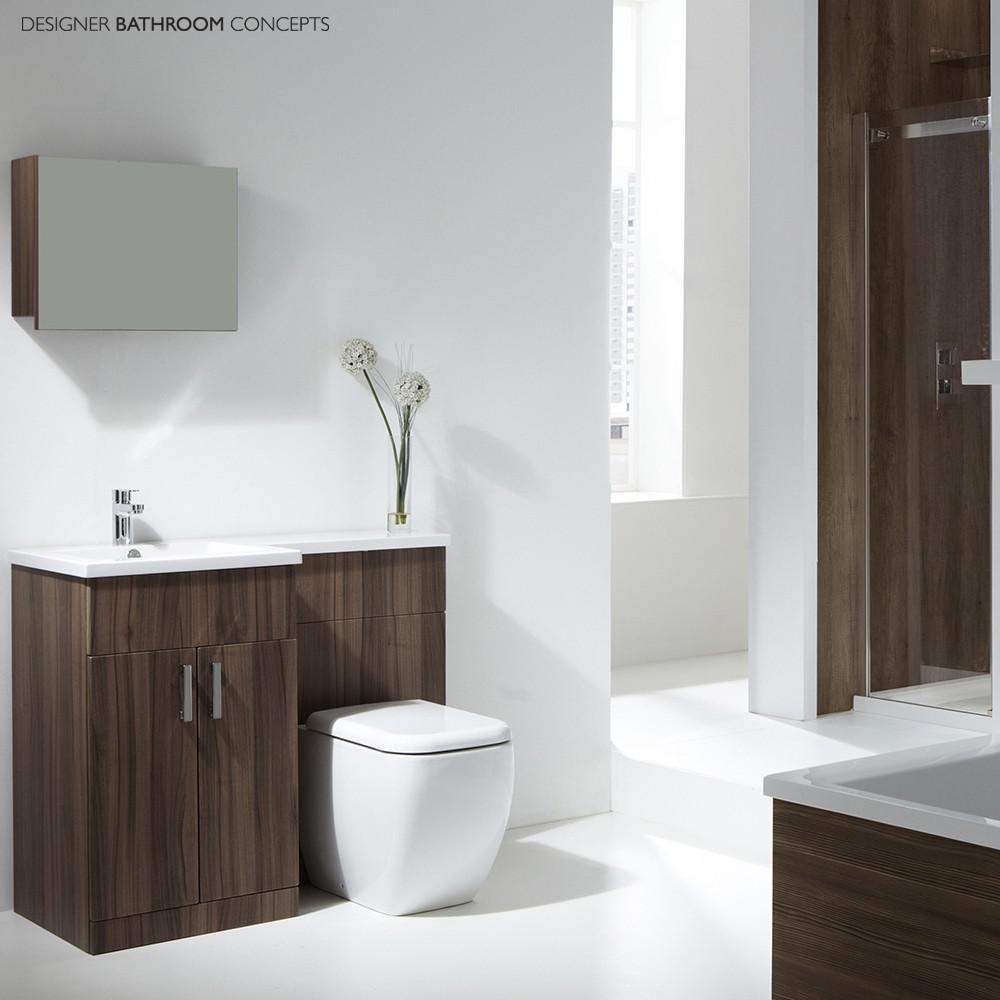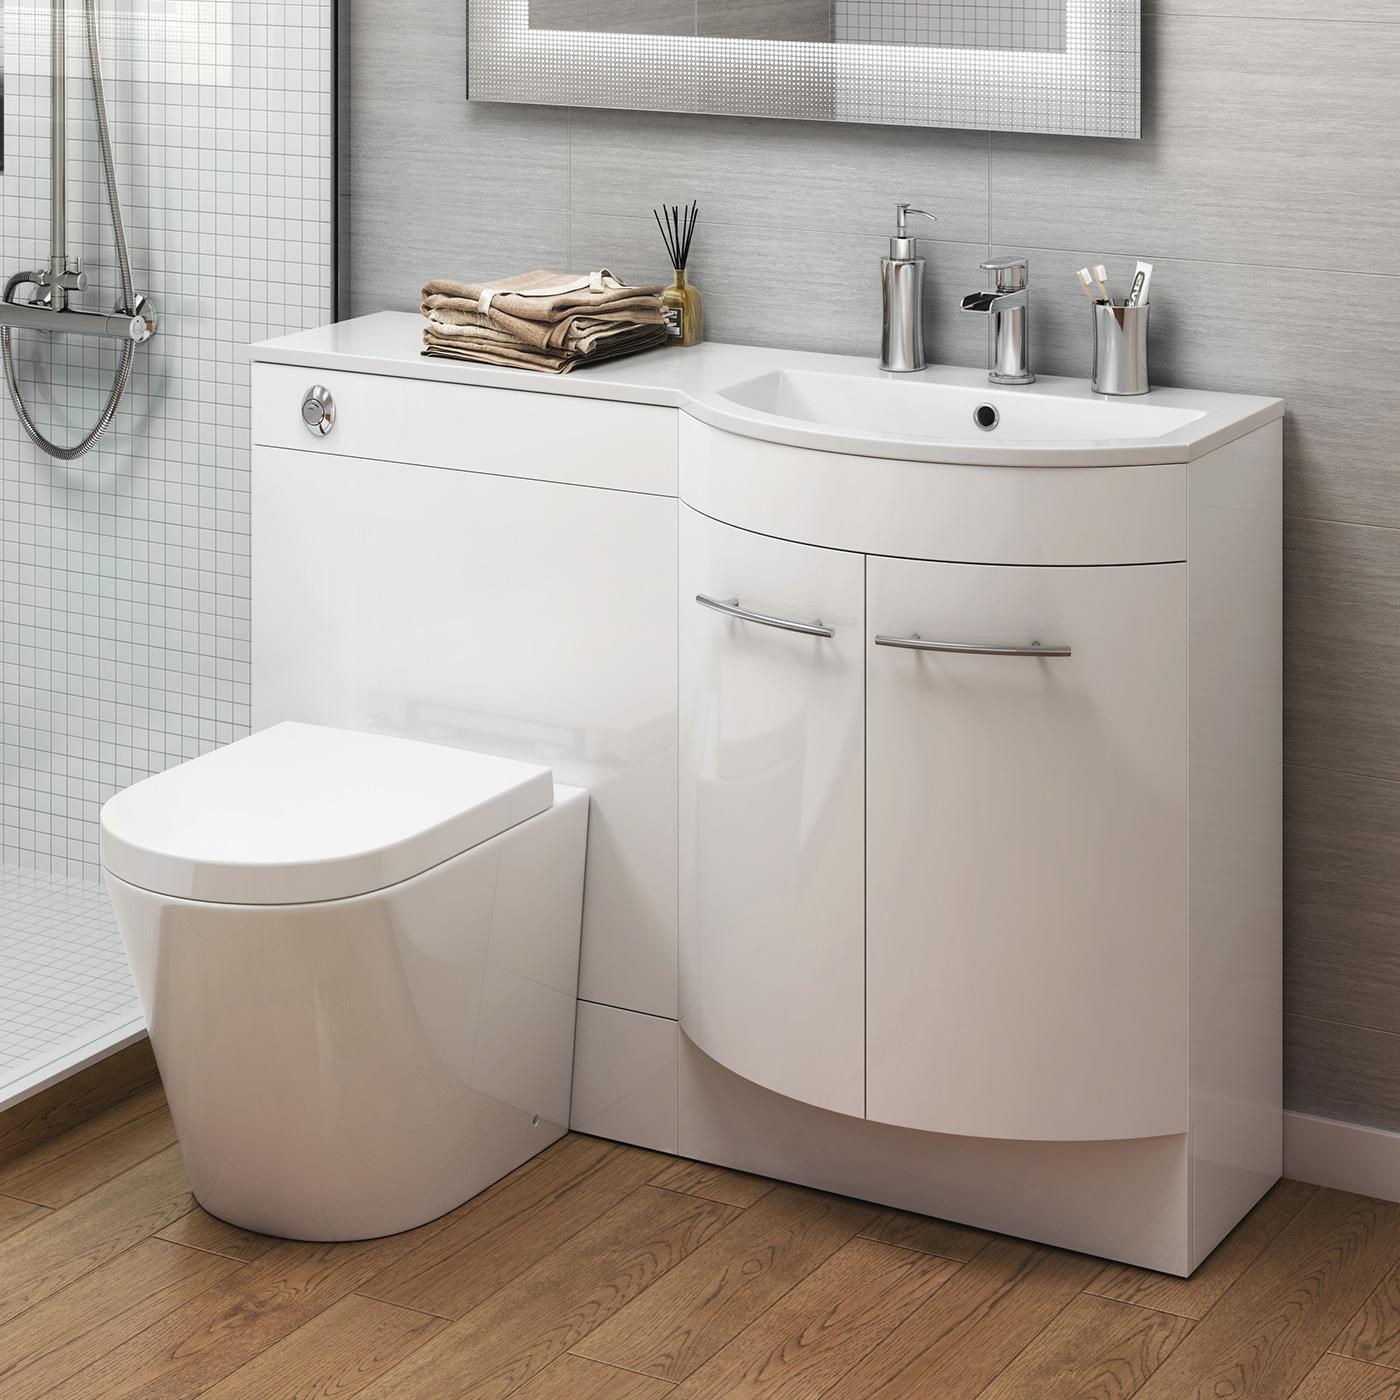The first image is the image on the left, the second image is the image on the right. Analyze the images presented: Is the assertion "One of the toilets is connected to a wood cabinet." valid? Answer yes or no. Yes. The first image is the image on the left, the second image is the image on the right. For the images displayed, is the sentence "A white commode is attached at one end of a white vanity, with a white sink attached at the other end over double doors." factually correct? Answer yes or no. Yes. 